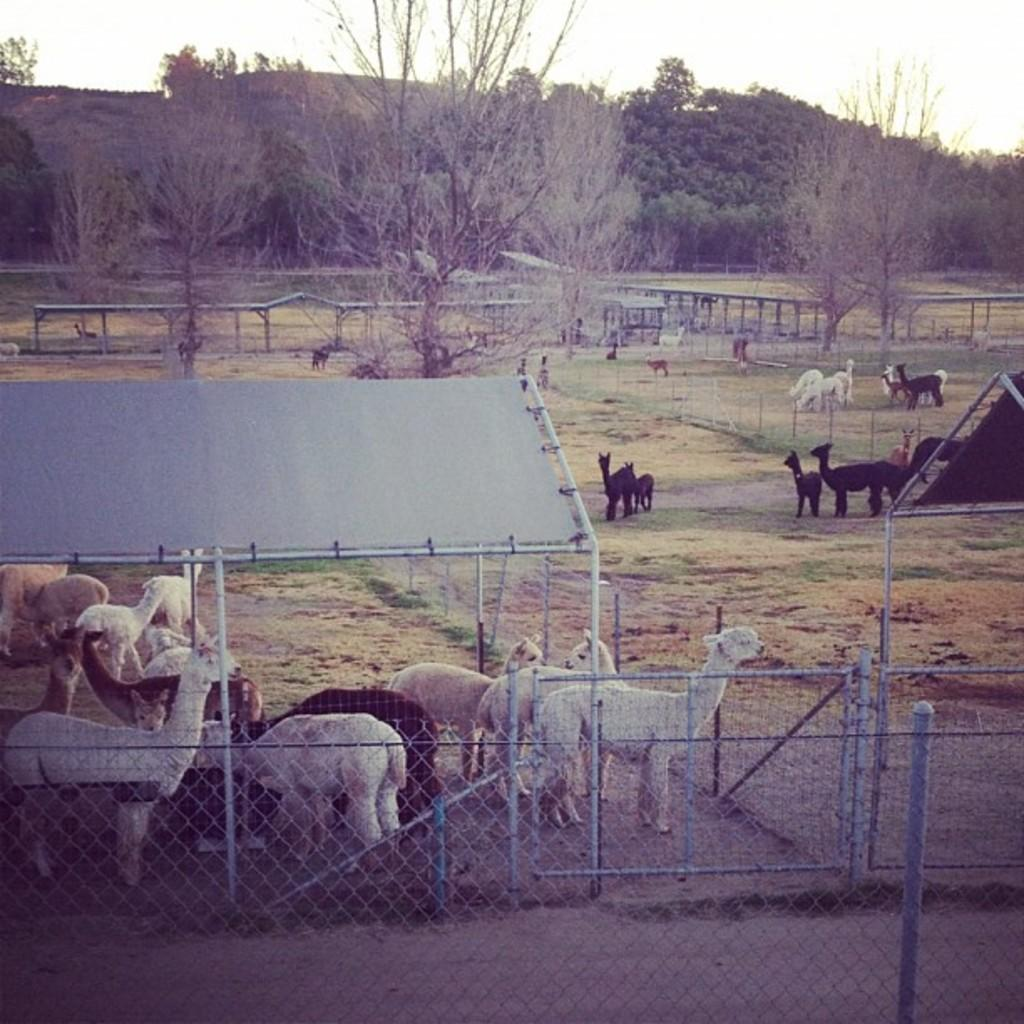What can be seen on the path in the image? There are animals on the path in the image. What type of barrier is present in the image? There is fencing from left to right in the image. What can be seen in the distance in the image? There are trees in the background of the image. Where is the class located in the image? There is no class present in the image. Can you see any jellyfish in the image? There are no jellyfish present in the image. 